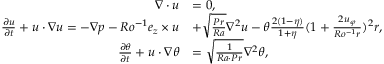Convert formula to latex. <formula><loc_0><loc_0><loc_500><loc_500>\begin{array} { r l } { \nabla \cdot u } & { = 0 , } \\ { \frac { \partial u } { \partial t } + u \cdot \nabla u = - \nabla p - R o ^ { - 1 } e _ { z } \times u } & { + \sqrt { \frac { P r } { R a } } \nabla ^ { 2 } u - \theta \frac { 2 ( 1 - \eta ) } { 1 + \eta } ( 1 + \frac { 2 u _ { \varphi } } { R o ^ { - 1 } r } ) ^ { 2 } r , } \\ { \frac { \partial \theta } { \partial t } + u \cdot \nabla \theta } & { = \sqrt { \frac { 1 } { R a \cdot P r } } \nabla ^ { 2 } \theta , } \end{array}</formula> 